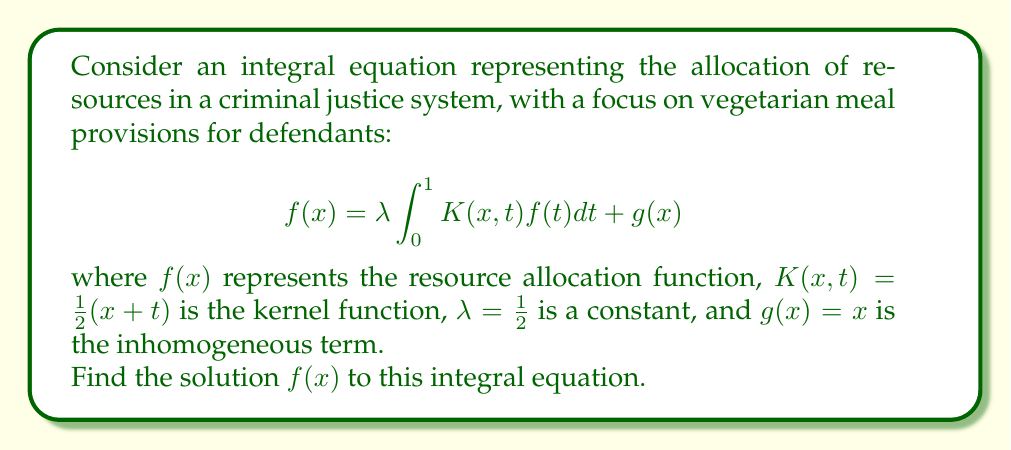Teach me how to tackle this problem. To solve this integral equation, we'll use the method of successive approximations:

1) Start with an initial guess: $f_0(x) = g(x) = x$

2) Use the iterative formula:
   $$f_{n+1}(x) = \lambda \int_0^1 K(x,t)f_n(t)dt + g(x)$$

3) First iteration:
   $$\begin{align*}
   f_1(x) &= \frac{1}{2} \int_0^1 \frac{1}{2}(x+t)t dt + x \\
   &= \frac{1}{4}x \int_0^1 t dt + \frac{1}{4} \int_0^1 t^2 dt + x \\
   &= \frac{1}{4}x \cdot \frac{1}{2} + \frac{1}{4} \cdot \frac{1}{3} + x \\
   &= \frac{1}{8}x + \frac{1}{12} + x \\
   &= \frac{9}{8}x + \frac{1}{12}
   \end{align*}$$

4) Second iteration:
   $$\begin{align*}
   f_2(x) &= \frac{1}{2} \int_0^1 \frac{1}{2}(x+t)(\frac{9}{8}t + \frac{1}{12}) dt + x \\
   &= \frac{1}{4}x \int_0^1 (\frac{9}{8}t + \frac{1}{12}) dt + \frac{1}{4} \int_0^1 t(\frac{9}{8}t + \frac{1}{12}) dt + x \\
   &= \frac{1}{4}x (\frac{9}{16} + \frac{1}{12}) + \frac{1}{4} (\frac{3}{8} + \frac{1}{24}) + x \\
   &= \frac{23}{48}x + \frac{11}{96} + x \\
   &= \frac{71}{48}x + \frac{11}{96}
   \end{align*}$$

5) The pattern emerges: $f_n(x) = a_nx + b_n$, where $\{a_n\}$ and $\{b_n\}$ are sequences.

6) As $n \to \infty$, these sequences converge to:
   $$a_{\infty} = \frac{4}{3}, \quad b_{\infty} = \frac{1}{9}$$

Therefore, the solution to the integral equation is:
$$f(x) = \frac{4}{3}x + \frac{1}{9}$$

This can be verified by substituting back into the original equation.
Answer: $f(x) = \frac{4}{3}x + \frac{1}{9}$ 